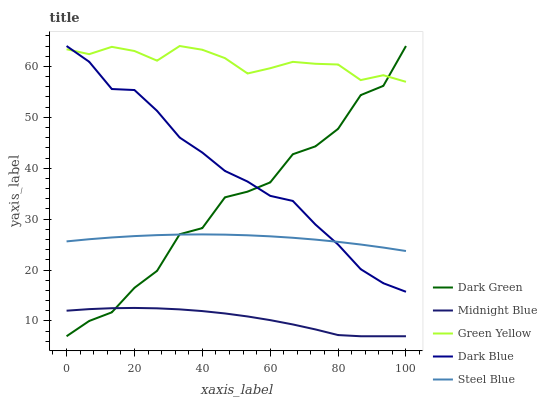Does Midnight Blue have the minimum area under the curve?
Answer yes or no. Yes. Does Green Yellow have the maximum area under the curve?
Answer yes or no. Yes. Does Steel Blue have the minimum area under the curve?
Answer yes or no. No. Does Steel Blue have the maximum area under the curve?
Answer yes or no. No. Is Steel Blue the smoothest?
Answer yes or no. Yes. Is Dark Green the roughest?
Answer yes or no. Yes. Is Green Yellow the smoothest?
Answer yes or no. No. Is Green Yellow the roughest?
Answer yes or no. No. Does Steel Blue have the lowest value?
Answer yes or no. No. Does Steel Blue have the highest value?
Answer yes or no. No. Is Midnight Blue less than Steel Blue?
Answer yes or no. Yes. Is Green Yellow greater than Steel Blue?
Answer yes or no. Yes. Does Midnight Blue intersect Steel Blue?
Answer yes or no. No. 